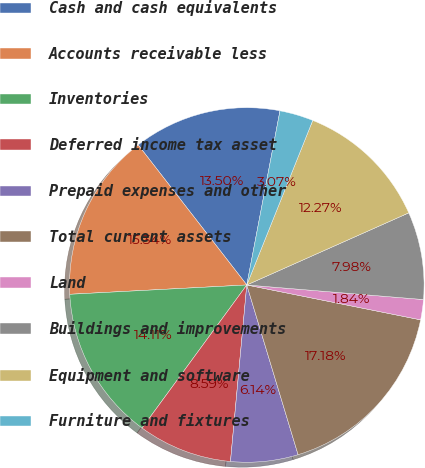Convert chart. <chart><loc_0><loc_0><loc_500><loc_500><pie_chart><fcel>Cash and cash equivalents<fcel>Accounts receivable less<fcel>Inventories<fcel>Deferred income tax asset<fcel>Prepaid expenses and other<fcel>Total current assets<fcel>Land<fcel>Buildings and improvements<fcel>Equipment and software<fcel>Furniture and fixtures<nl><fcel>13.5%<fcel>15.34%<fcel>14.11%<fcel>8.59%<fcel>6.14%<fcel>17.18%<fcel>1.84%<fcel>7.98%<fcel>12.27%<fcel>3.07%<nl></chart> 